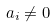Convert formula to latex. <formula><loc_0><loc_0><loc_500><loc_500>a _ { i } \neq 0</formula> 